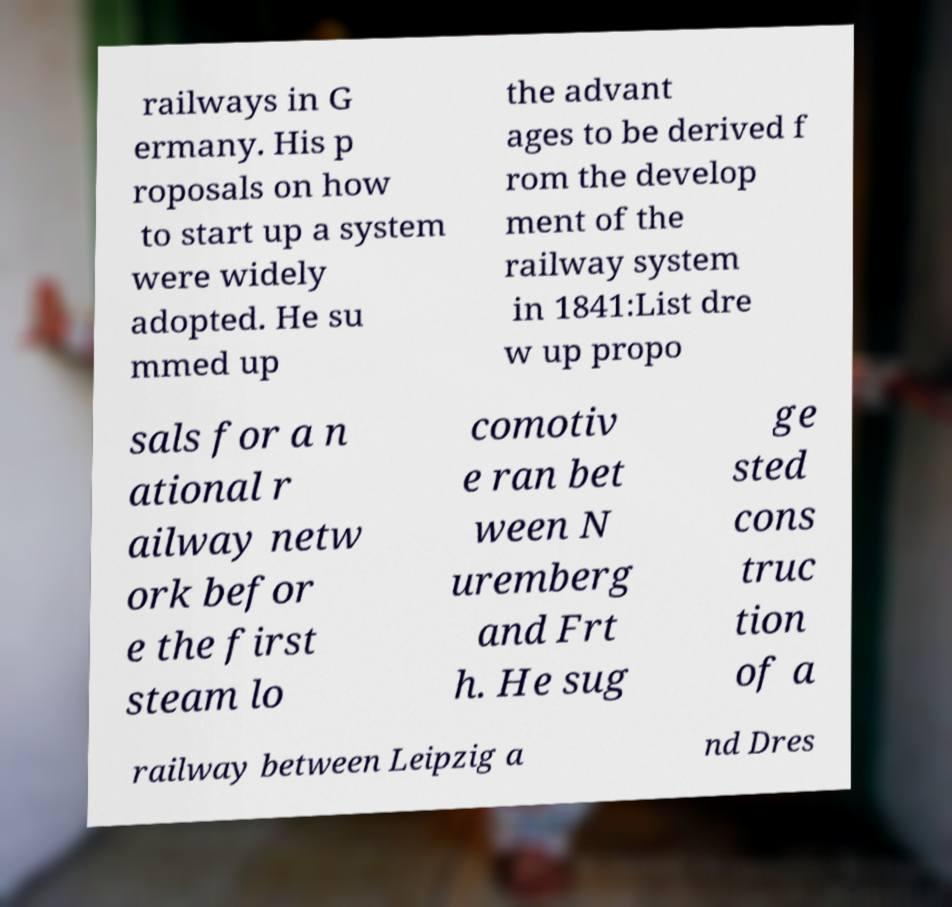Please read and relay the text visible in this image. What does it say? railways in G ermany. His p roposals on how to start up a system were widely adopted. He su mmed up the advant ages to be derived f rom the develop ment of the railway system in 1841:List dre w up propo sals for a n ational r ailway netw ork befor e the first steam lo comotiv e ran bet ween N uremberg and Frt h. He sug ge sted cons truc tion of a railway between Leipzig a nd Dres 